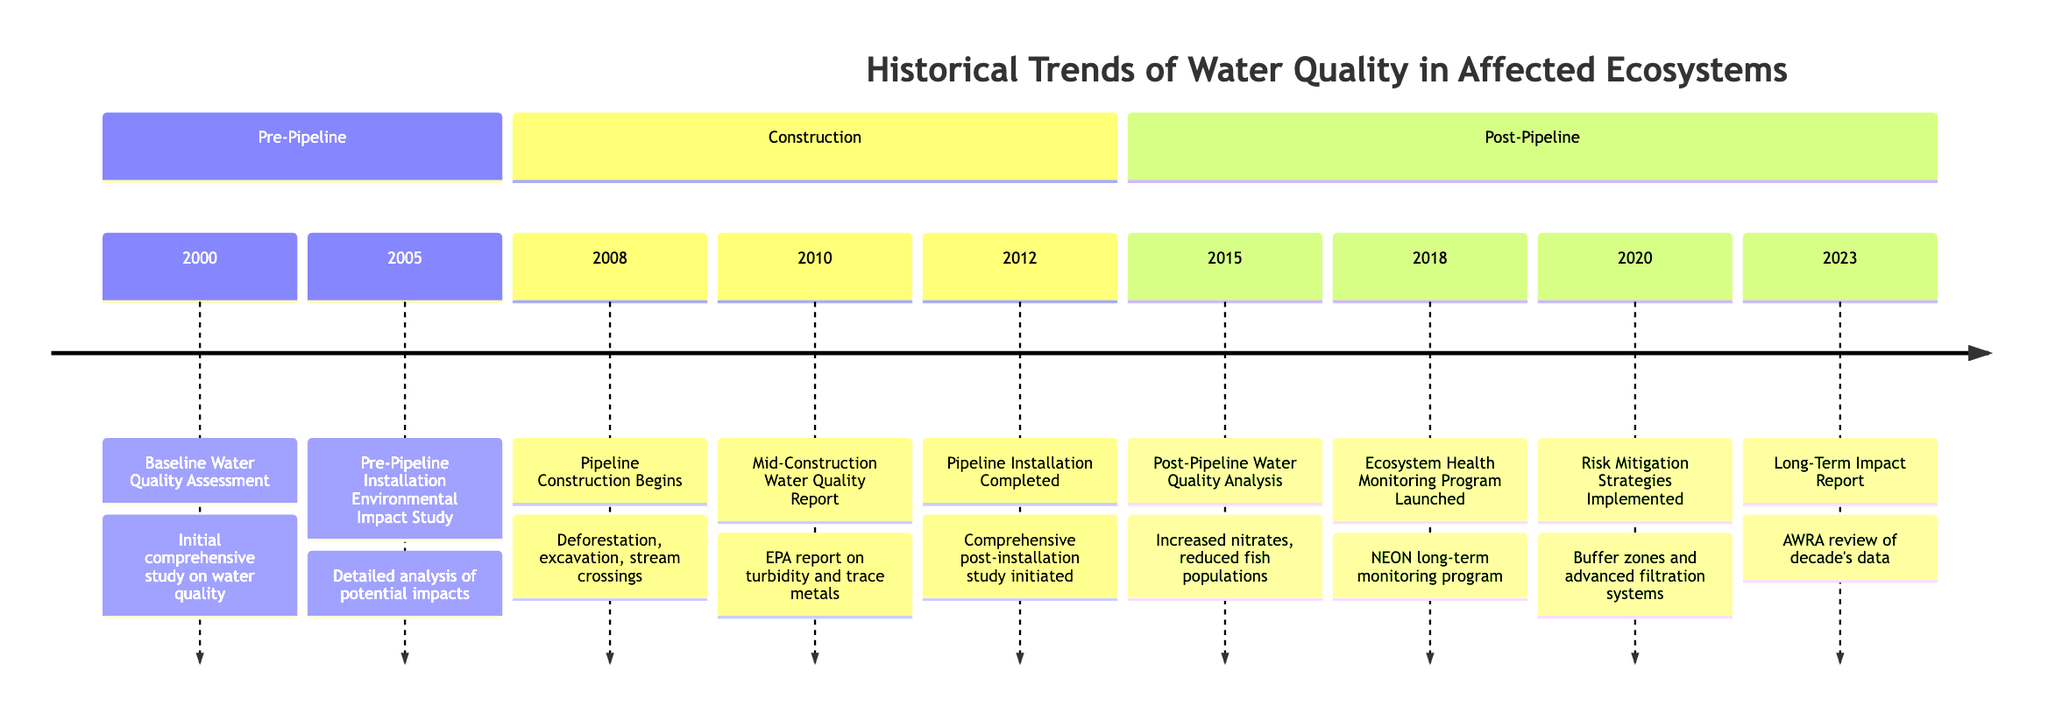What year did the Baseline Water Quality Assessment occur? The timeline indicates that the Baseline Water Quality Assessment was conducted in the year 2000. This is explicitly stated as the first event under the Pre-Pipeline section.
Answer: 2000 What was the main focus of the Pre-Pipeline Installation Environmental Impact Study? The Pre-Pipeline Installation Environmental Impact Study, recorded in 2005, focused on detailed analysis of potential impacts on water quality and ecosystems, particularly in regions like Deer Valley and Blue Lake. Thus, the main focus was environmental impact analysis.
Answer: Environmental impact analysis Which agency produced the Mid-Construction Water Quality Report? The Mid-Construction Water Quality Report from 2010 was produced by the Environmental Protection Agency (EPA). This information is provided in the description of the event in the Construction section.
Answer: Environmental Protection Agency What trend was observed in the Post-Pipeline Water Quality Analysis in 2015? The Post-Pipeline Water Quality Analysis conducted in 2015 showed significant findings including increased nitrate levels and reduced fish populations in specific areas such as Clear Creek and Pine Lake. Thus, the observed trend was an increase in nitrate levels and a decrease in fish populations.
Answer: Increased nitrates, reduced fish populations What significant program was launched in 2018? In 2018, a significant program called the Ecosystem Health Monitoring Program was launched by the National Ecological Observatory Network (NEON). This program is focused on long-term monitoring of water quality and ecosystem health. Therefore, the answer to the original question is the Ecosystem Health Monitoring Program.
Answer: Ecosystem Health Monitoring Program What year marked the completion of the pipeline installation? The timeline indicates that the Pipeline Installation was completed in 2012. This event is described as the pipeline being fully operational, marking a key point in the timeline.
Answer: 2012 What risk mitigation strategies were implemented in 2020? In 2020, risk mitigation strategies such as buffer zones and advanced filtration systems were introduced to address potential pipeline leaks and their impact on water sources. This detail is provided in the description of that year's event.
Answer: Buffer zones and advanced filtration systems What was the outcome of the Long-Term Impact Report in 2023? The Long-Term Impact Report, which was completed in 2023, revealed trends in pollutant levels, biodiversity changes, and the efficacy of mitigation efforts based on a decade's worth of data. Therefore, the outcome summarized is an assessment of water quality trends and mitigation effectiveness.
Answer: Trends in pollutant levels, biodiversity changes What type of monitoring was established in the 2018 program? The monitoring established in the 2018 program was a long-term monitoring program, specifically aimed at assessing the ongoing impacts on water quality and ecosystem health. This is explicitly detailed in the event description for that year.
Answer: Long-term monitoring program 